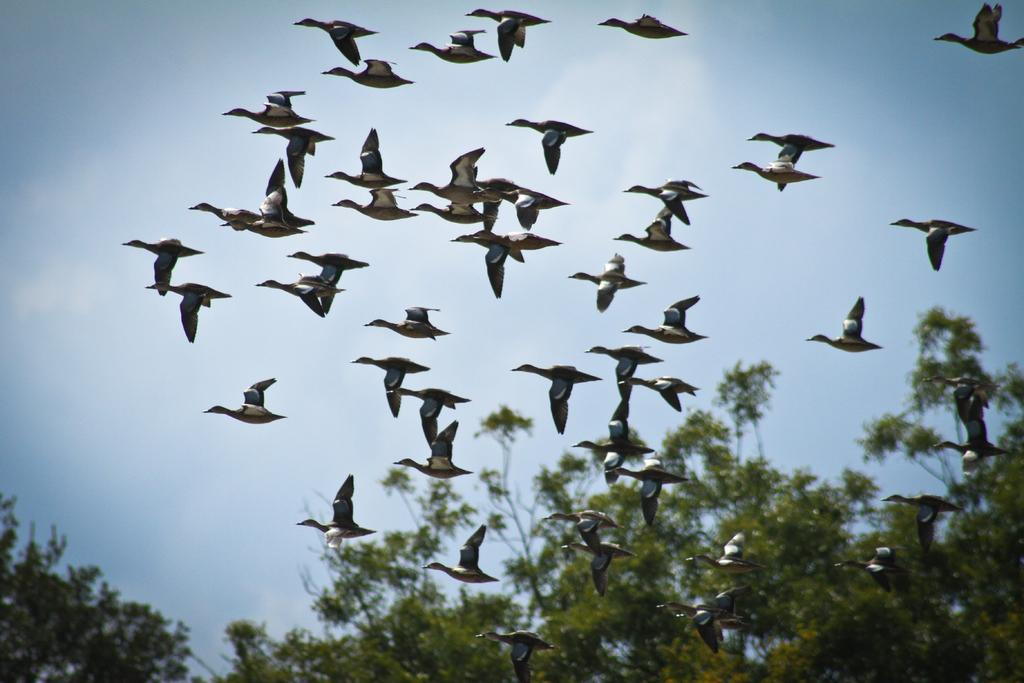What type of animals can be seen in the image? There is a herd of birds in the image. What part of the natural environment is visible in the image? The sky is visible in the image. What type of vegetation is present at the bottom of the image? Trees are present at the bottom of the image. What type of arch can be seen in the image? There is no arch present in the image; it features a herd of birds, the sky, and trees. 